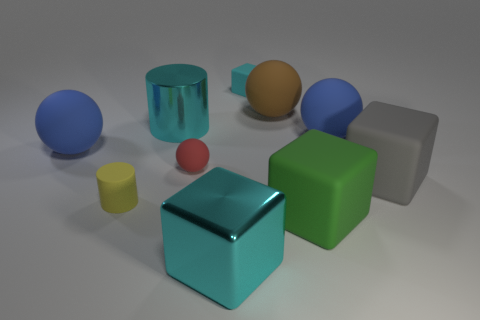Subtract all tiny cyan blocks. How many blocks are left? 3 Subtract all red balls. How many balls are left? 3 Subtract 2 cylinders. How many cylinders are left? 0 Subtract all blocks. How many objects are left? 6 Subtract all gray balls. How many red cylinders are left? 0 Add 10 big yellow metal cubes. How many big yellow metal cubes exist? 10 Subtract 0 gray cylinders. How many objects are left? 10 Subtract all yellow blocks. Subtract all blue balls. How many blocks are left? 4 Subtract all large blue matte spheres. Subtract all tiny cyan blocks. How many objects are left? 7 Add 6 big blue balls. How many big blue balls are left? 8 